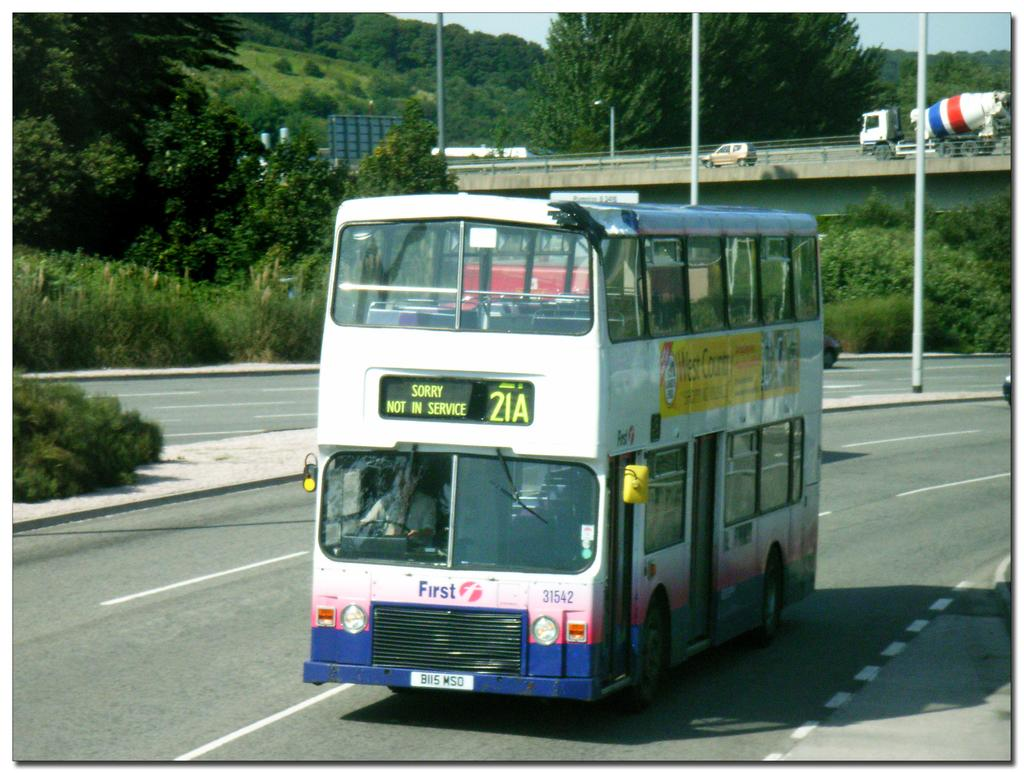<image>
Give a short and clear explanation of the subsequent image. A bus on the road has a digital sign that informs it is not in service. 